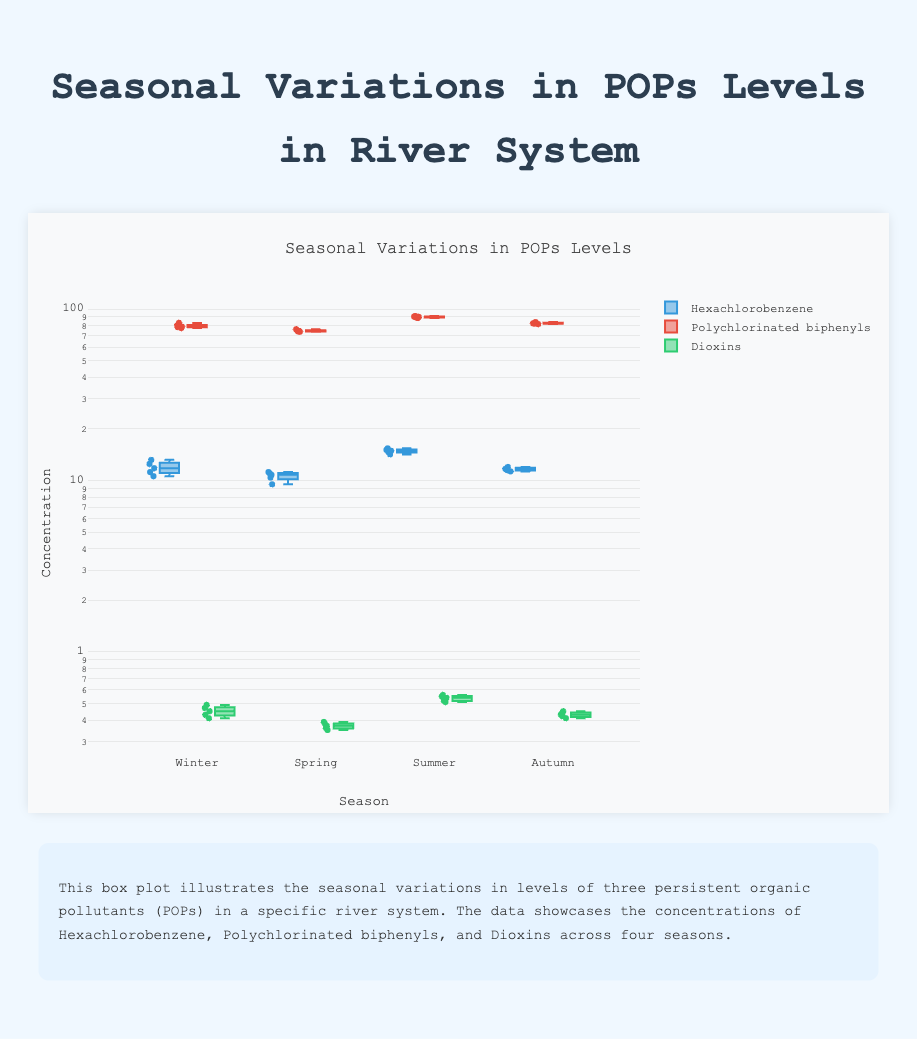what is the title of the plot? The title is located at the top of the plot and summarizes the content of the figure.
Answer: Seasonal Variations in POPs Levels what is represented on the x-axis? The x-axis of the plot shows different seasons. Each season corresponds to a category that the data is segmented into.
Answer: Season what color represents Hexachlorobenzene? Each pollutant is represented by a specific color. Hexachlorobenzene is represented by the color blue.
Answer: Blue which pollutant has the highest concentration during Summer? By examining the concentrations during Summer, it can be observed that Polychlorinated biphenyls have the highest concentration among the three pollutants.
Answer: Polychlorinated biphenyls what's the median value of Dioxins in Spring? The median value is the middle point of the data when arranged in ascending order. For Dioxins in Spring, the values are ordered as 0.35, 0.36, 0.37, 0.38, 0.39. The median value is the one in the middle, 0.37.
Answer: 0.37 compare the interquartile range (IQR) of Hexachlorobenzene between Winter and Autumn The IQR is the range between the first and third quartiles. In the box plot, this range is represented by the box. By comparing the sizes of the boxes for Winter and Autumn, we determine which has a larger or smaller spread.
Answer: Winter has a larger IQR which season has the lowest average level of Hexachlorobenzene? The average is calculated by summing the values and dividing by the number of data points. By calculating the average for each season, Spring has the lowest average level.
Answer: Spring is there any outlier in the levels of Polychlorinated biphenyls in any season? An outlier in a box plot is a point that is far removed from the other data points. By observing the plot, no such outliers are apparent in the Polychlorinated biphenyls data.
Answer: No during which season are the Dioxins levels more tightly clustered? In a box plot, a tighter cluster indicates a smaller IQR and closer data points. By observing the plots, Spring shows the Dioxins levels are most tightly clustered.
Answer: Spring which season has the highest range of Dioxins levels? The range is calculated by subtracting the minimum value from the maximum value. By looking at the Dioxins data across the seasons, Summer has the highest range.
Answer: Summer 